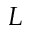Convert formula to latex. <formula><loc_0><loc_0><loc_500><loc_500>L</formula> 